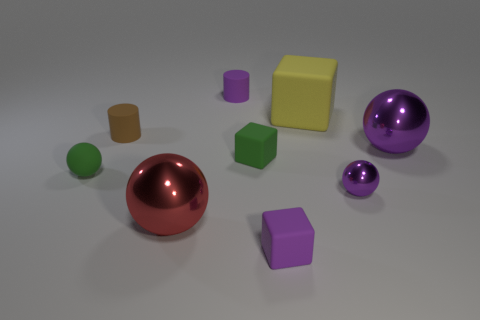Add 1 small green spheres. How many objects exist? 10 Subtract all spheres. How many objects are left? 5 Add 9 green blocks. How many green blocks are left? 10 Add 3 purple metallic balls. How many purple metallic balls exist? 5 Subtract 0 blue cylinders. How many objects are left? 9 Subtract all tiny rubber blocks. Subtract all big yellow rubber cubes. How many objects are left? 6 